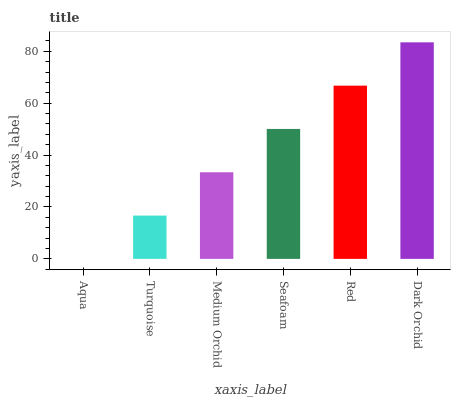Is Aqua the minimum?
Answer yes or no. Yes. Is Dark Orchid the maximum?
Answer yes or no. Yes. Is Turquoise the minimum?
Answer yes or no. No. Is Turquoise the maximum?
Answer yes or no. No. Is Turquoise greater than Aqua?
Answer yes or no. Yes. Is Aqua less than Turquoise?
Answer yes or no. Yes. Is Aqua greater than Turquoise?
Answer yes or no. No. Is Turquoise less than Aqua?
Answer yes or no. No. Is Seafoam the high median?
Answer yes or no. Yes. Is Medium Orchid the low median?
Answer yes or no. Yes. Is Turquoise the high median?
Answer yes or no. No. Is Seafoam the low median?
Answer yes or no. No. 